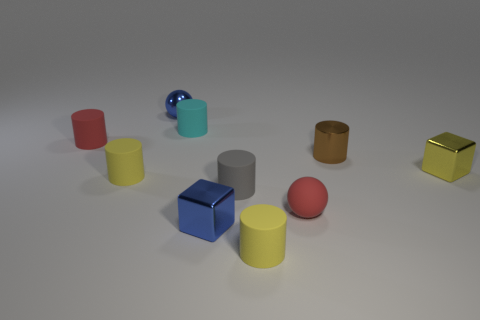There is a blue thing that is in front of the red cylinder; what material is it?
Offer a terse response. Metal. Is there anything else that has the same size as the gray cylinder?
Your answer should be compact. Yes. Is the number of large gray things less than the number of blocks?
Provide a succinct answer. Yes. There is a small shiny object that is both in front of the small blue metal ball and to the left of the tiny brown metallic cylinder; what is its shape?
Offer a very short reply. Cube. What number of small yellow metal cubes are there?
Your response must be concise. 1. What material is the yellow thing that is in front of the cube that is left of the small cube on the right side of the metallic cylinder?
Offer a very short reply. Rubber. There is a tiny yellow rubber cylinder that is on the right side of the small metallic ball; what number of rubber cylinders are in front of it?
Give a very brief answer. 0. There is a metal thing that is the same shape as the cyan matte object; what color is it?
Your answer should be very brief. Brown. Are the red cylinder and the tiny brown object made of the same material?
Make the answer very short. No. How many cylinders are either blue shiny objects or tiny yellow rubber objects?
Make the answer very short. 2. 